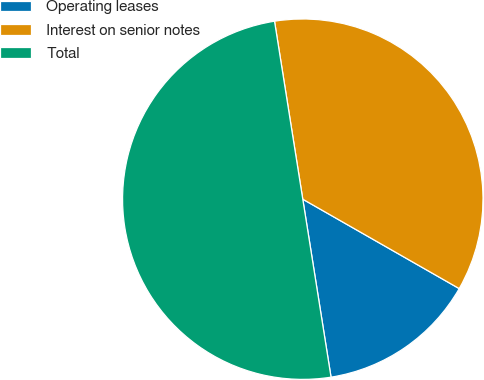<chart> <loc_0><loc_0><loc_500><loc_500><pie_chart><fcel>Operating leases<fcel>Interest on senior notes<fcel>Total<nl><fcel>14.23%<fcel>35.77%<fcel>50.0%<nl></chart> 